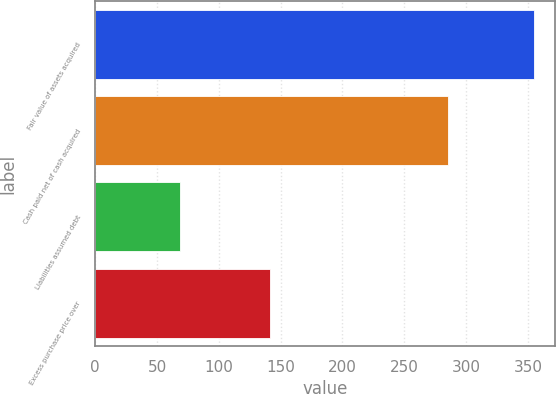Convert chart. <chart><loc_0><loc_0><loc_500><loc_500><bar_chart><fcel>Fair value of assets acquired<fcel>Cash paid net of cash acquired<fcel>Liabilities assumed debt<fcel>Excess purchase price over<nl><fcel>354.6<fcel>285.8<fcel>68.8<fcel>141.6<nl></chart> 